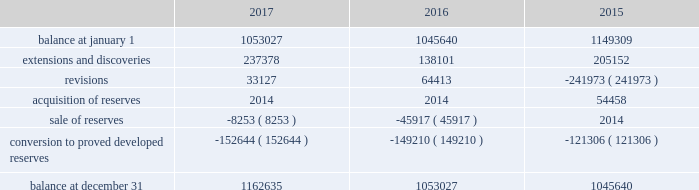Eog resources , inc .
Supplemental information to consolidated financial statements ( continued ) net proved undeveloped reserves .
The table presents the changes in eog's total proved undeveloped reserves during 2017 , 2016 and 2015 ( in mboe ) : .
For the twelve-month period ended december 31 , 2017 , total puds increased by 110 mmboe to 1163 mmboe .
Eog added approximately 38 mmboe of puds through drilling activities where the wells were drilled but significant expenditures remained for completion .
Based on the technology employed by eog to identify and record puds ( see discussion of technology employed on pages f-38 and f-39 of this annual report on form 10-k ) , eog added 199 mmboe .
The pud additions were primarily in the permian basin and , to a lesser extent , the eagle ford and the rocky mountain area , and 74% ( 74 % ) of the additions were crude oil and condensate and ngls .
During 2017 , eog drilled and transferred 153 mmboe of puds to proved developed reserves at a total capital cost of $ 1440 million .
Revisions of puds totaled positive 33 mmboe , primarily due to updated type curves resulting from improved performance of offsetting wells in the permian basin , the impact of increases in the average crude oil and natural gas prices used in the december 31 , 2017 , reserves estimation as compared to the prices used in the prior year estimate , and lower costs .
During 2017 , eog sold or exchanged 8 mmboe of puds primarily in the permian basin .
All puds , including drilled but uncompleted wells ( ducs ) , are scheduled for completion within five years of the original reserve booking .
For the twelve-month period ended december 31 , 2016 , total puds increased by 7 mmboe to 1053 mmboe .
Eog added approximately 21 mmboe of puds through drilling activities where the wells were drilled but significant expenditures remained for completion .
Based on the technology employed by eog to identify and record puds , eog added 117 mmboe .
The pud additions were primarily in the permian basin and , to a lesser extent , the rocky mountain area , and 82% ( 82 % ) of the additions were crude oil and condensate and ngls .
During 2016 , eog drilled and transferred 149 mmboe of puds to proved developed reserves at a total capital cost of $ 1230 million .
Revisions of puds totaled positive 64 mmboe , primarily due to improved well performance , primarily in the delaware basin , and lower production costs , partially offset by the impact of decreases in the average crude oil and natural gas prices used in the december 31 , 2016 , reserves estimation as compared to the prices used in the prior year estimate .
During 2016 , eog sold 46 mmboe of puds primarily in the haynesville play .
All puds for drilled but uncompleted wells ( ducs ) are scheduled for completion within five years of the original reserve booking .
For the twelve-month period ended december 31 , 2015 , total puds decreased by 104 mmboe to 1046 mmboe .
Eog added approximately 52 mmboe of puds through drilling activities where the wells were drilled but significant expenditures remained for completion .
Based on the technology employed by eog to identify and record puds , eog added 153 mmboe .
The pud additions were primarily in the permian basin and , to a lesser extent , the eagle ford and the rocky mountain area , and 80% ( 80 % ) of the additions were crude oil and condensate and ngls .
During 2015 , eog drilled and transferred 121 mmboe of puds to proved developed reserves at a total capital cost of $ 2349 million .
Revisions of puds totaled negative 242 mmboe , primarily due to decreases in the average crude oil and natural gas prices used in the december 31 , 2015 , reserves estimation as compared to the prices used in the prior year estimate .
During 2015 , eog did not sell any puds and acquired 54 mmboe of puds. .
What is the highest initial balance observed during 2015-2017? 
Rationale: it is the maximum value for this period .
Computations: table_max(balance at january 1, none)
Answer: 1149309.0. 